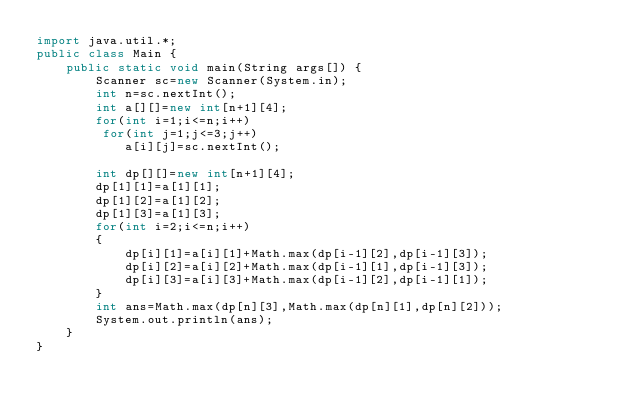<code> <loc_0><loc_0><loc_500><loc_500><_Java_>import java.util.*;
public class Main {
    public static void main(String args[]) {
        Scanner sc=new Scanner(System.in);
        int n=sc.nextInt();
        int a[][]=new int[n+1][4];
        for(int i=1;i<=n;i++)
         for(int j=1;j<=3;j++)
            a[i][j]=sc.nextInt();

        int dp[][]=new int[n+1][4];
        dp[1][1]=a[1][1];
        dp[1][2]=a[1][2];
        dp[1][3]=a[1][3];
        for(int i=2;i<=n;i++)
        {
            dp[i][1]=a[i][1]+Math.max(dp[i-1][2],dp[i-1][3]);
            dp[i][2]=a[i][2]+Math.max(dp[i-1][1],dp[i-1][3]);
            dp[i][3]=a[i][3]+Math.max(dp[i-1][2],dp[i-1][1]);
        }
        int ans=Math.max(dp[n][3],Math.max(dp[n][1],dp[n][2]));
        System.out.println(ans); 
    }
}</code> 